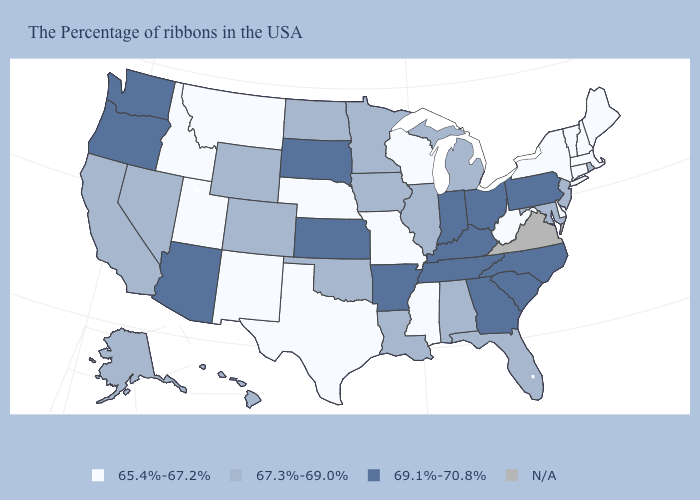What is the value of West Virginia?
Answer briefly. 65.4%-67.2%. Among the states that border Washington , does Idaho have the lowest value?
Give a very brief answer. Yes. Among the states that border North Dakota , which have the highest value?
Answer briefly. South Dakota. Does the map have missing data?
Answer briefly. Yes. How many symbols are there in the legend?
Keep it brief. 4. What is the value of Washington?
Give a very brief answer. 69.1%-70.8%. Among the states that border Maryland , which have the lowest value?
Give a very brief answer. Delaware, West Virginia. What is the lowest value in the MidWest?
Give a very brief answer. 65.4%-67.2%. Does Nebraska have the lowest value in the USA?
Keep it brief. Yes. Does Pennsylvania have the lowest value in the Northeast?
Quick response, please. No. What is the value of Oregon?
Give a very brief answer. 69.1%-70.8%. Does Pennsylvania have the highest value in the Northeast?
Write a very short answer. Yes. What is the value of South Carolina?
Give a very brief answer. 69.1%-70.8%. 